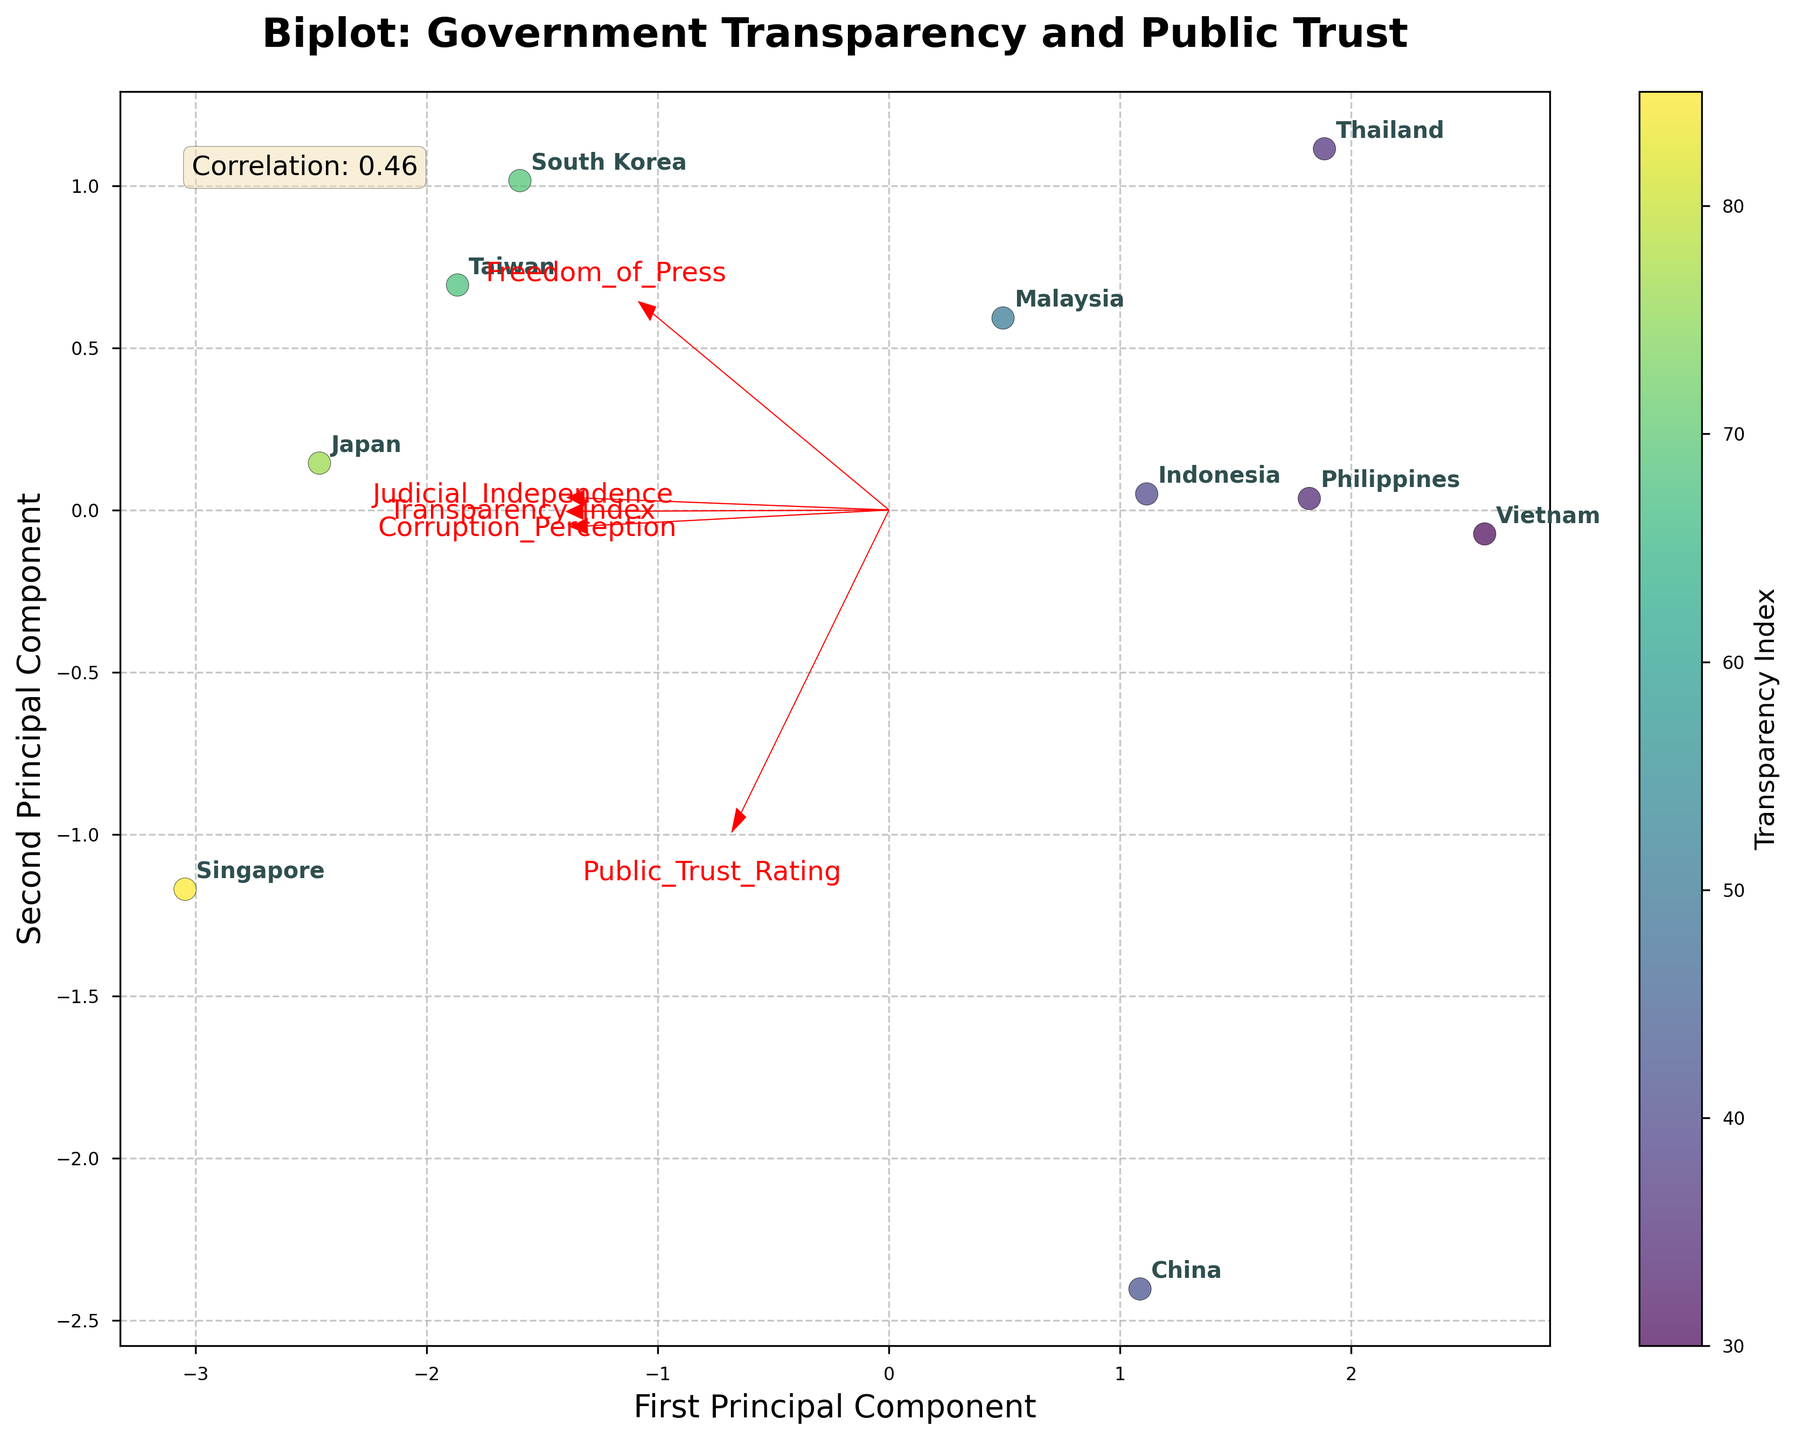Which country has the highest Transparency Index according to the biplot? By looking at the scatter plot, each country's data point is color-coded by their Transparency Index. The country with the most intense color (indicating the highest transparency index) is Singapore.
Answer: Singapore How many principal components are displayed in this biplot? The biplot typically shows the first two principal components on the x and y axes, which is indicated by the axis labels "First Principal Component" and "Second Principal Component".
Answer: 2 Which feature has the longest vector on the biplot, suggesting it has the highest variance in the dataset? The longest vector can be identified by comparing the lengths of the arrows emanating from the origin. The feature with the longest arrow, indicating the highest variance, is "Transparency_Index".
Answer: Transparency_Index What is the approximate correlation between the Transparency Index and Public Trust Rating? The correlation coefficient between the Transparency Index and Public Trust Rating is shown in the figure's caption as approximately 0.71. This value is derived using Pearson's correlation.
Answer: 0.71 Compare the Public Trust Rating of Vietnam and China based on the biplot. Which country has a higher rating? By observing the positioning of Vietnam and China on the plot and their corresponding Public Trust Rating, China has a higher rating as it's further along the color gradient compared to Vietnam.
Answer: China What can you infer about the relationship between Freedom of Press and Transparency Index from the biplot? By analyzing the direction and length of the vectors for Freedom of Press and Transparency Index, you can infer that they are somewhat orthogonal, suggesting a weak correlation between these two features.
Answer: Weak correlation Which country appears closest to the origin (0,0) on the biplot? The country closest to the origin can be identified by its proximity to the point where the principal component axes intersect. By visual estimation, Thailand appears closest to the origin.
Answer: Thailand Are there any countries whose Public Trust Rating is vastly higher than their Transparency Index as shown on the biplot? According to the biplot, China has a Public Trust Rating that is significantly higher than its Transparency Index, indicating a discrepancy between the public's trust and the government's transparency.
Answer: China Which two features are most aligned with each other, indicating a strong correlation in the biplot? The two features whose vectors point in the most similar direction and are the most aligned are Transparency Index and Corruption Perception, suggesting a strong positive correlation between them.
Answer: Transparency Index and Corruption Perception What does the colorbar represent in this biplot? The colorbar indicates the Transparency Index of each country. The colors range from lighter shades (indicating lower transparency) to darker shades (indicating higher transparency).
Answer: Transparency Index 